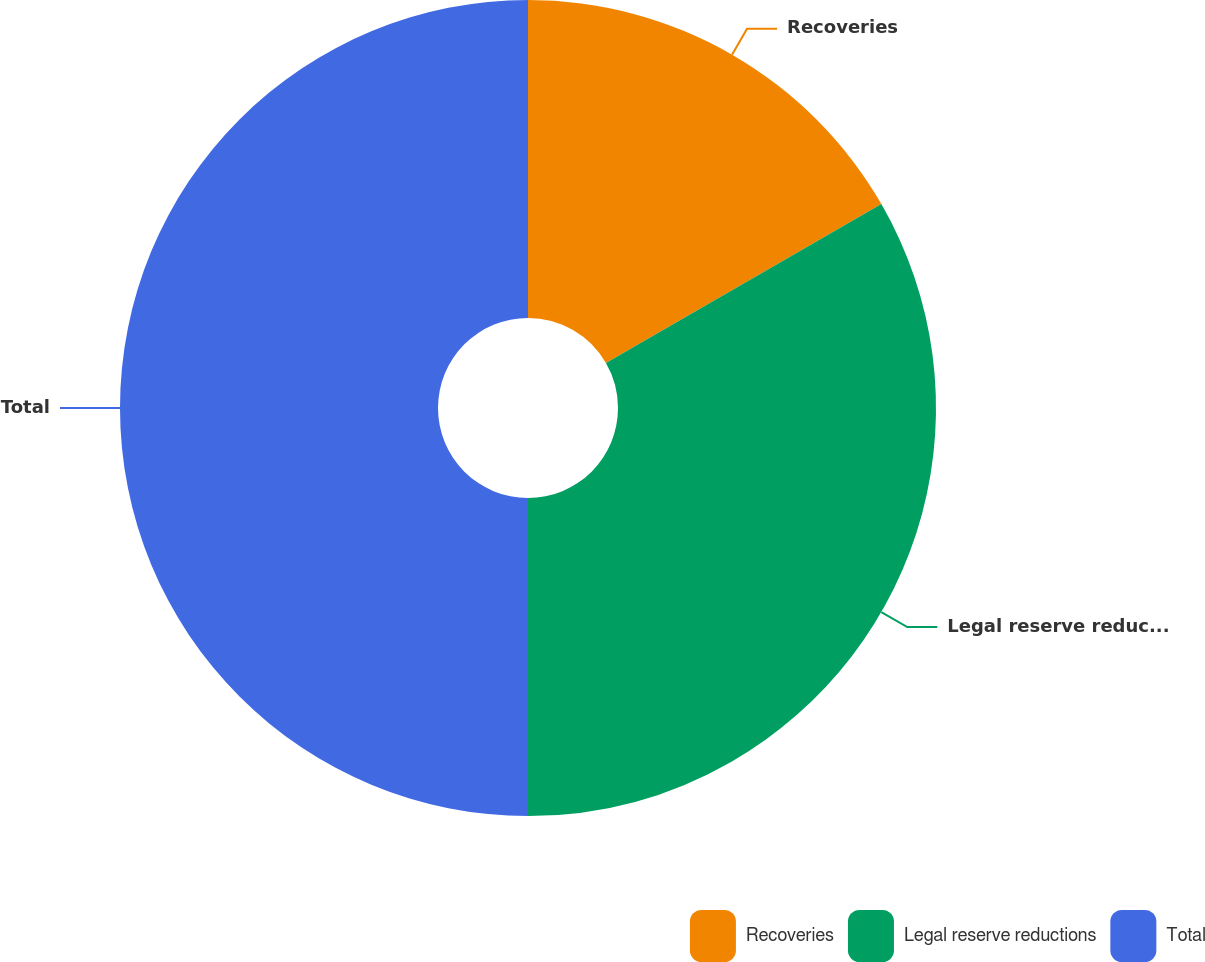<chart> <loc_0><loc_0><loc_500><loc_500><pie_chart><fcel>Recoveries<fcel>Legal reserve reductions<fcel>Total<nl><fcel>16.67%<fcel>33.33%<fcel>50.0%<nl></chart> 